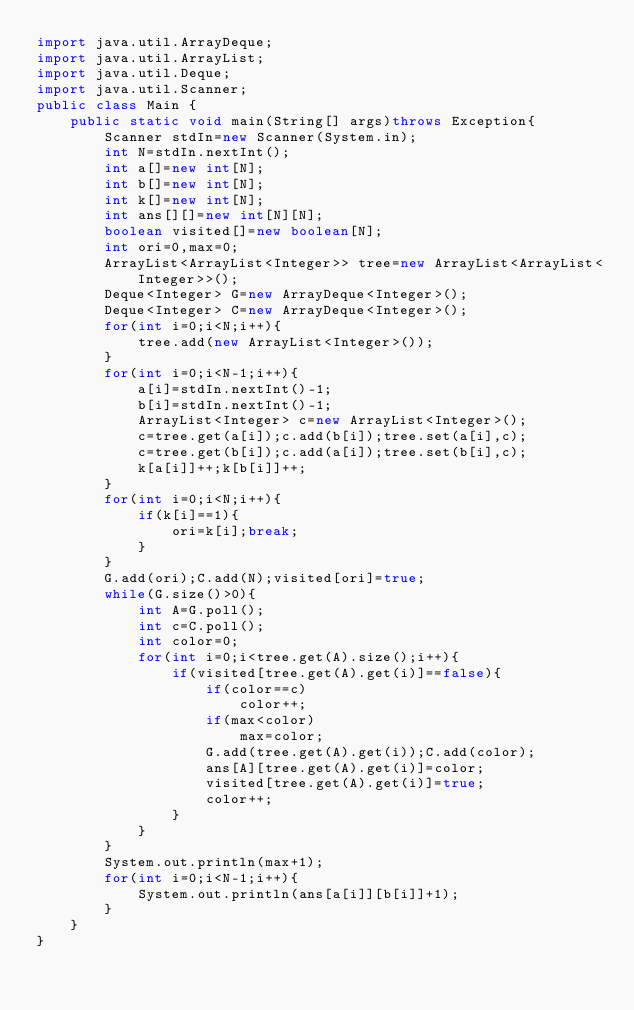Convert code to text. <code><loc_0><loc_0><loc_500><loc_500><_Java_>import java.util.ArrayDeque;
import java.util.ArrayList;
import java.util.Deque;
import java.util.Scanner;
public class Main {
	public static void main(String[] args)throws Exception{
		Scanner stdIn=new Scanner(System.in);
		int N=stdIn.nextInt();
		int a[]=new int[N];
		int b[]=new int[N];
		int k[]=new int[N];
		int ans[][]=new int[N][N];
		boolean visited[]=new boolean[N];
		int ori=0,max=0;
		ArrayList<ArrayList<Integer>> tree=new ArrayList<ArrayList<Integer>>();
		Deque<Integer> G=new ArrayDeque<Integer>();
		Deque<Integer> C=new ArrayDeque<Integer>(); 
		for(int i=0;i<N;i++){
			tree.add(new ArrayList<Integer>());
		}
		for(int i=0;i<N-1;i++){
			a[i]=stdIn.nextInt()-1;
			b[i]=stdIn.nextInt()-1;
			ArrayList<Integer> c=new ArrayList<Integer>();
			c=tree.get(a[i]);c.add(b[i]);tree.set(a[i],c);
			c=tree.get(b[i]);c.add(a[i]);tree.set(b[i],c);
			k[a[i]]++;k[b[i]]++;
		}
		for(int i=0;i<N;i++){
			if(k[i]==1){
				ori=k[i];break;
			}
		}
		G.add(ori);C.add(N);visited[ori]=true;
		while(G.size()>0){
			int A=G.poll();
			int c=C.poll();
			int color=0;
			for(int i=0;i<tree.get(A).size();i++){
				if(visited[tree.get(A).get(i)]==false){
					if(color==c)
						color++;
					if(max<color)
						max=color;
					G.add(tree.get(A).get(i));C.add(color);
					ans[A][tree.get(A).get(i)]=color;
					visited[tree.get(A).get(i)]=true;
					color++;
				}
			}
		}
		System.out.println(max+1);
		for(int i=0;i<N-1;i++){
			System.out.println(ans[a[i]][b[i]]+1);
		}
	}
}
</code> 